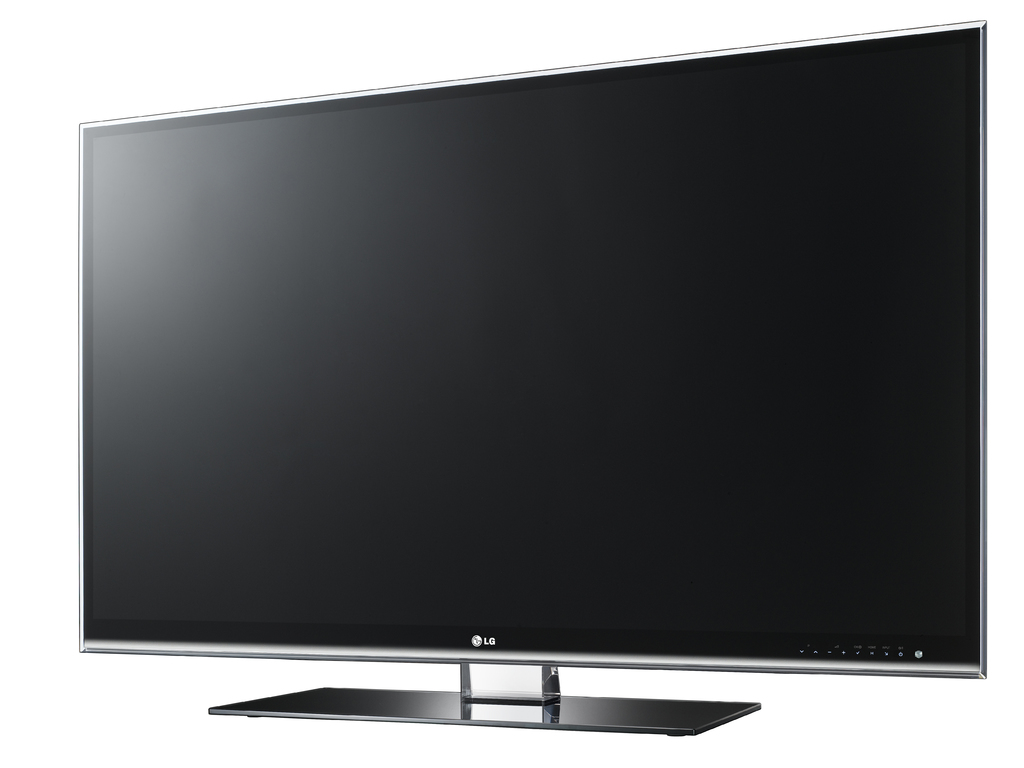Provide a one-sentence caption for the provided image. The image showcases a sleek, modern LG television featuring a large flat screen and minimalistic stand, ideal for contemporary living spaces. 